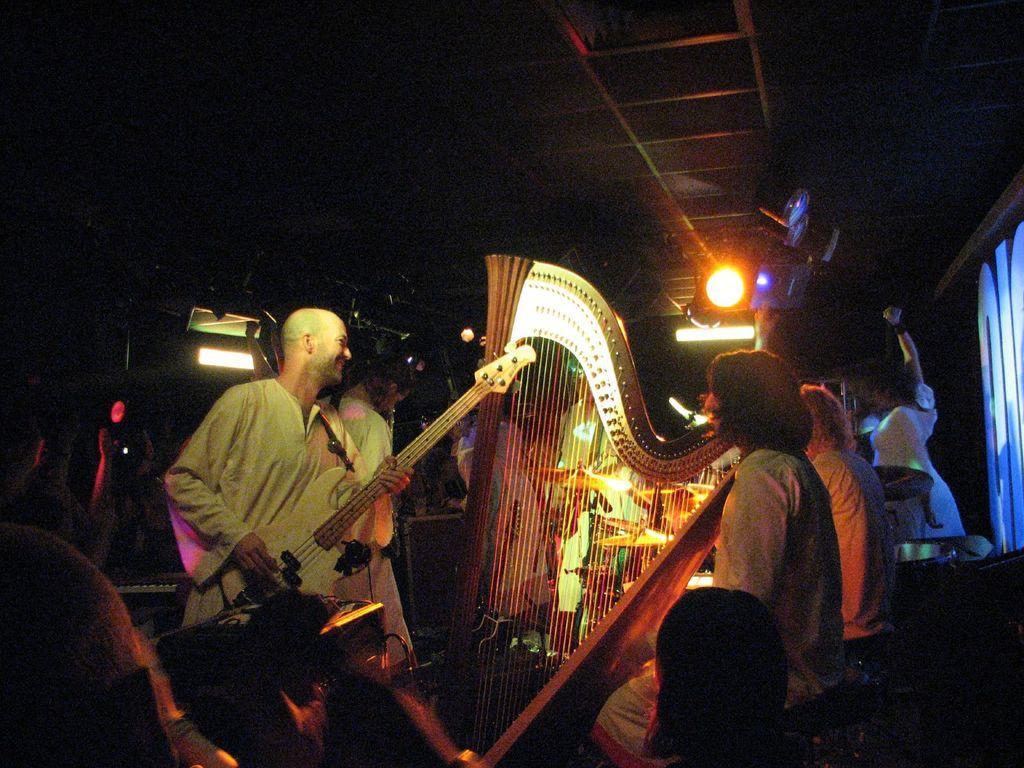Could you give a brief overview of what you see in this image? In this image I can see a person is holding musical instrument. I can see few people are sitting. Back I can see lights and dark background. 